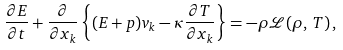<formula> <loc_0><loc_0><loc_500><loc_500>\frac { \partial E } { \partial t } + \frac { \partial } { \partial x _ { k } } \left \{ ( E + p ) v _ { k } - \kappa \frac { \partial T } { \partial x _ { k } } \right \} = - \rho \mathcal { L } ( \rho , \, T ) \, ,</formula> 